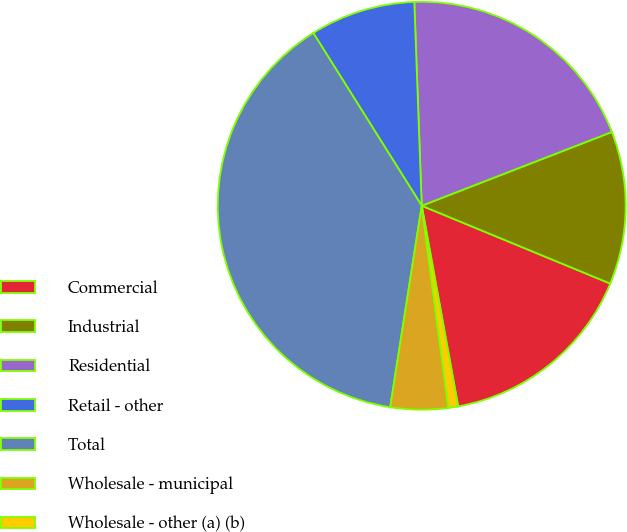<chart> <loc_0><loc_0><loc_500><loc_500><pie_chart><fcel>Commercial<fcel>Industrial<fcel>Residential<fcel>Retail - other<fcel>Total<fcel>Wholesale - municipal<fcel>Wholesale - other (a) (b)<nl><fcel>15.91%<fcel>12.12%<fcel>19.69%<fcel>8.34%<fcel>38.61%<fcel>4.56%<fcel>0.77%<nl></chart> 